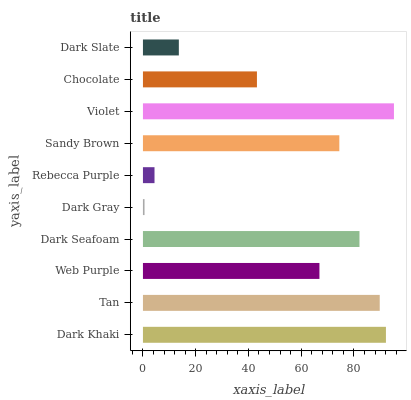Is Dark Gray the minimum?
Answer yes or no. Yes. Is Violet the maximum?
Answer yes or no. Yes. Is Tan the minimum?
Answer yes or no. No. Is Tan the maximum?
Answer yes or no. No. Is Dark Khaki greater than Tan?
Answer yes or no. Yes. Is Tan less than Dark Khaki?
Answer yes or no. Yes. Is Tan greater than Dark Khaki?
Answer yes or no. No. Is Dark Khaki less than Tan?
Answer yes or no. No. Is Sandy Brown the high median?
Answer yes or no. Yes. Is Web Purple the low median?
Answer yes or no. Yes. Is Dark Gray the high median?
Answer yes or no. No. Is Dark Gray the low median?
Answer yes or no. No. 